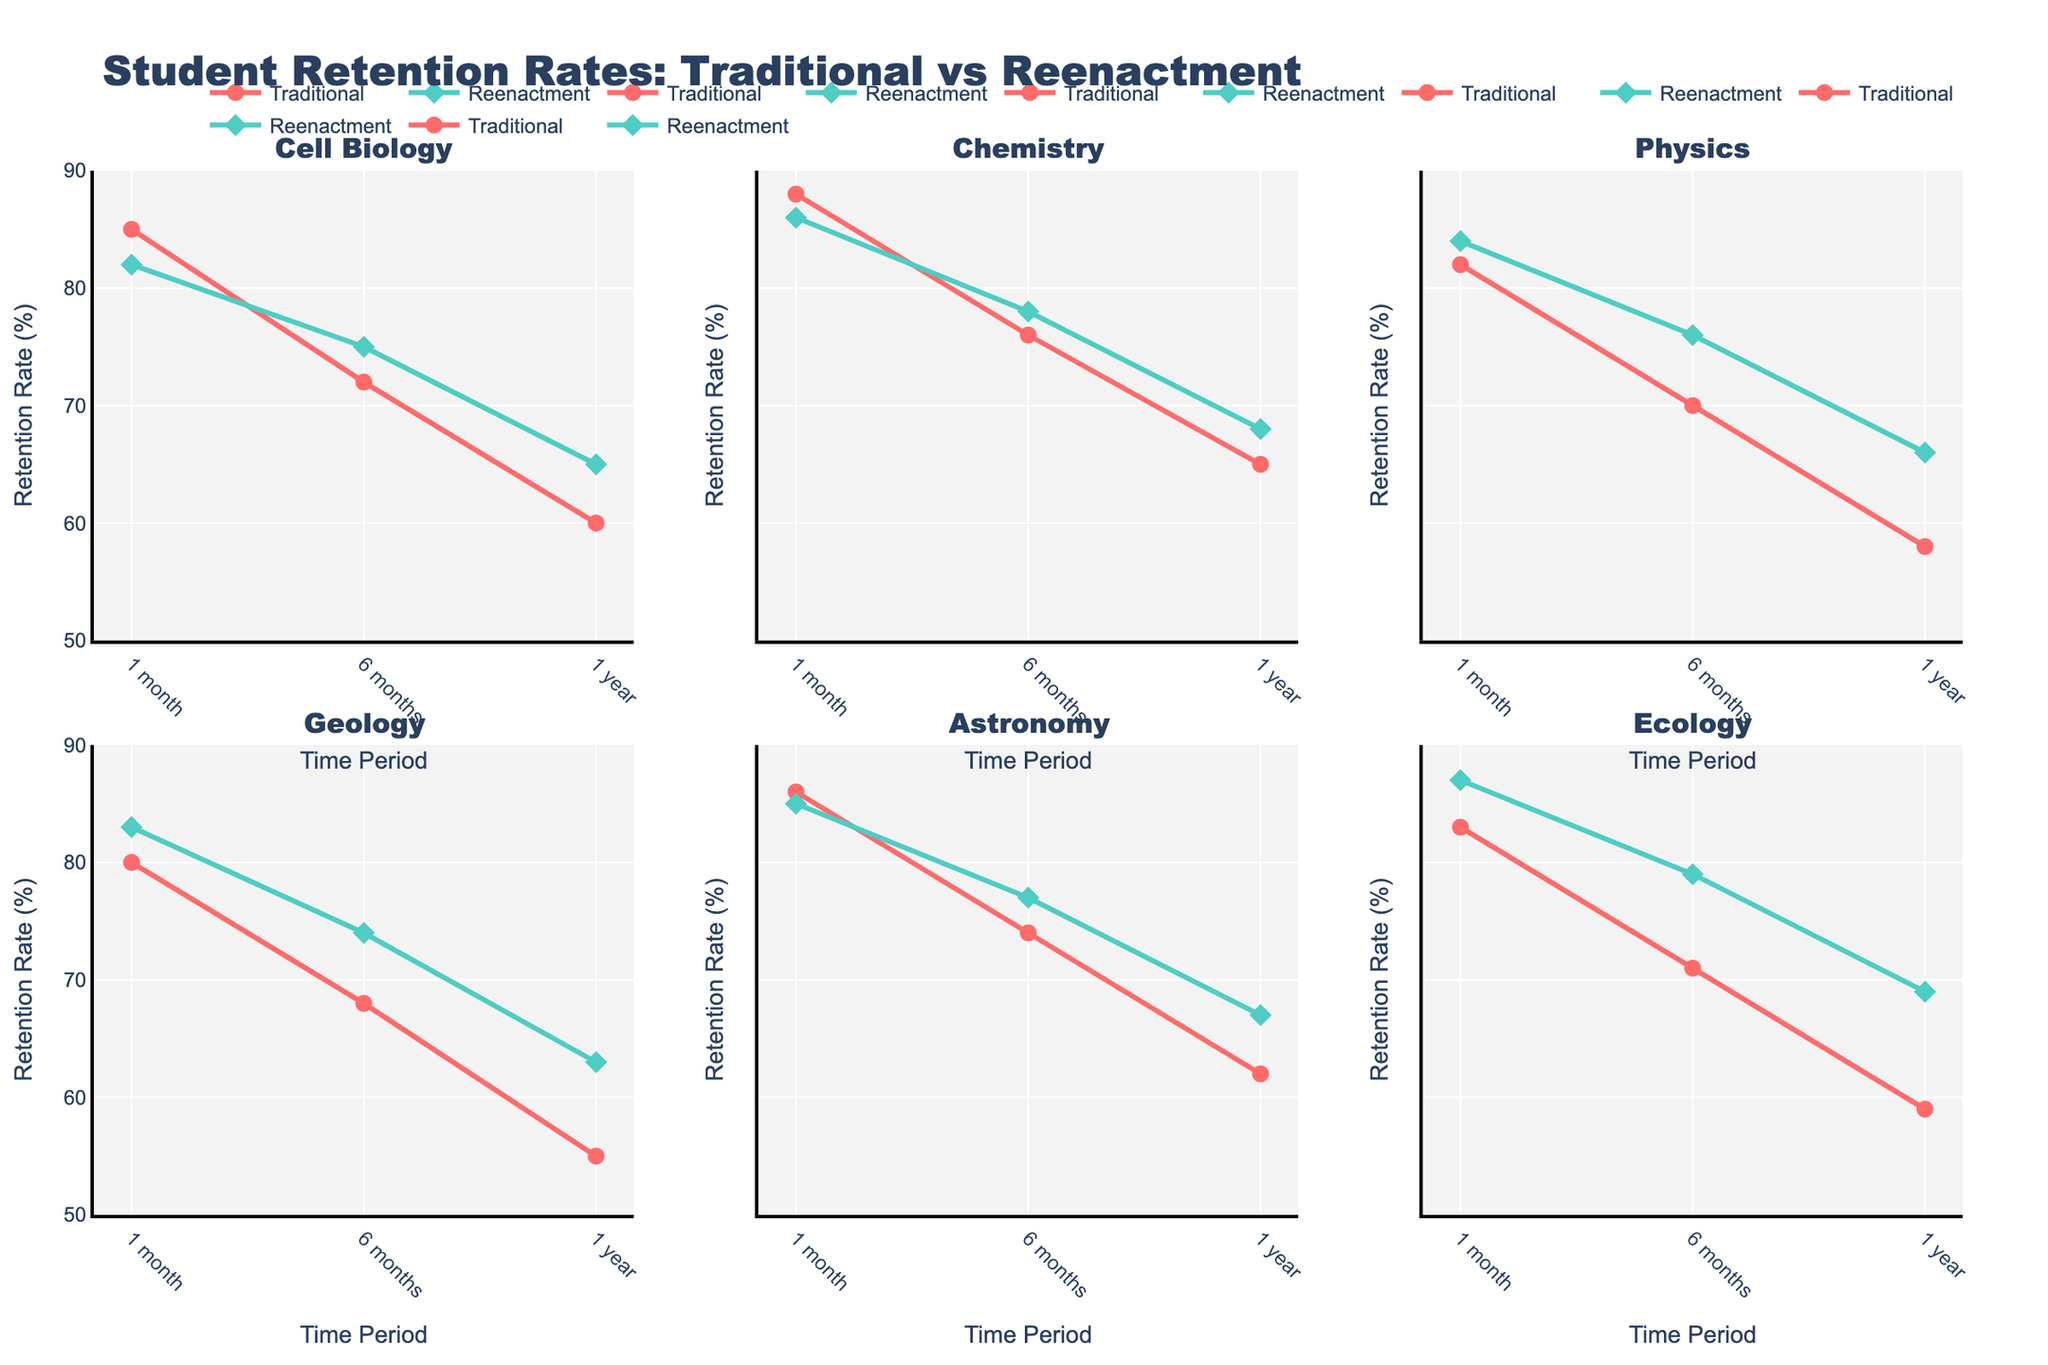Which region has the best air quality according to the Air Quality Index? The Air Quality Index subplot shows different regions and their indices. The lowest value indicates the best air quality; here, Mecklenburg-Vorpommern has the lowest index at 38.
Answer: Mecklenburg-Vorpommern What is the Renewable Energy Percentage for Brandenburg? The Renewable Energy Percentage subplot shows the values for each region. Brandenburg's renewable energy percentage is shown to be 63.8%.
Answer: 63.8% Which region recycles the most waste? The Waste Recycled Percentage subplot has bars representing waste recycling percentages for each region. Bavaria has the highest percentage at 67.2%.
Answer: Bavaria How does North Rhine-Westphalia's air quality compare to Bavaria's? The Air Quality Index subplot shows the indices for both regions. North Rhine-Westphalia has a higher index (56) compared to Bavaria (42), indicating worse air quality.
Answer: Worse Which two regions have the highest environmental performance score? The Environmental Performance subplot shows combined scores for all regions. Mecklenburg-Vorpommern and Bavaria have the highest scores based on their bar heights.
Answer: Mecklenburg-Vorpommern and Bavaria What is the difference in the Waste Recycled Percentage between Saxony and Hesse? In the Waste Recycled Percentage subplot, Saxony's percentage is 58.9%, and Hesse's is 59.5%. The difference is 59.5 - 58.9 = 0.6%.
Answer: 0.6% How does Thuringia's air quality index compare to the average air quality index? Calculate the average air quality index by summing all values and dividing by the number of regions. Then compare it to Thuringia's value. The average is (42 + 51 + 56 + 39 + 45 + 47 + 48 + 43 + 38 + 46) / 10 = 45.5. Thuringia's index is 43, which is better.
Answer: Better What is the air quality index range for the regions shown? Identify the lowest and highest values in the Air Quality Index subplot. The range is from Mecklenburg-Vorpommern (38) to North Rhine-Westphalia (56).
Answer: 38-56 Which region has the lowest renewable energy percentage? The Renewable Energy Percentage subplot shows all regions. North Rhine-Westphalia has the lowest percentage at 16.8%.
Answer: North Rhine-Westphalia What is the combined score for Lower Saxony? Calculate the combined score using the formula: (Max Air Quality Index - Region's Air Quality Index) / 10 + Renewable Energy Percentage / 100 + Waste Recycled Percentage / 100. For Lower Saxony: (56-45)/10 + 41.2/100 + 62.1/100 = 1.1 + 0.412 + 0.621 = 2.13.
Answer: 2.13 